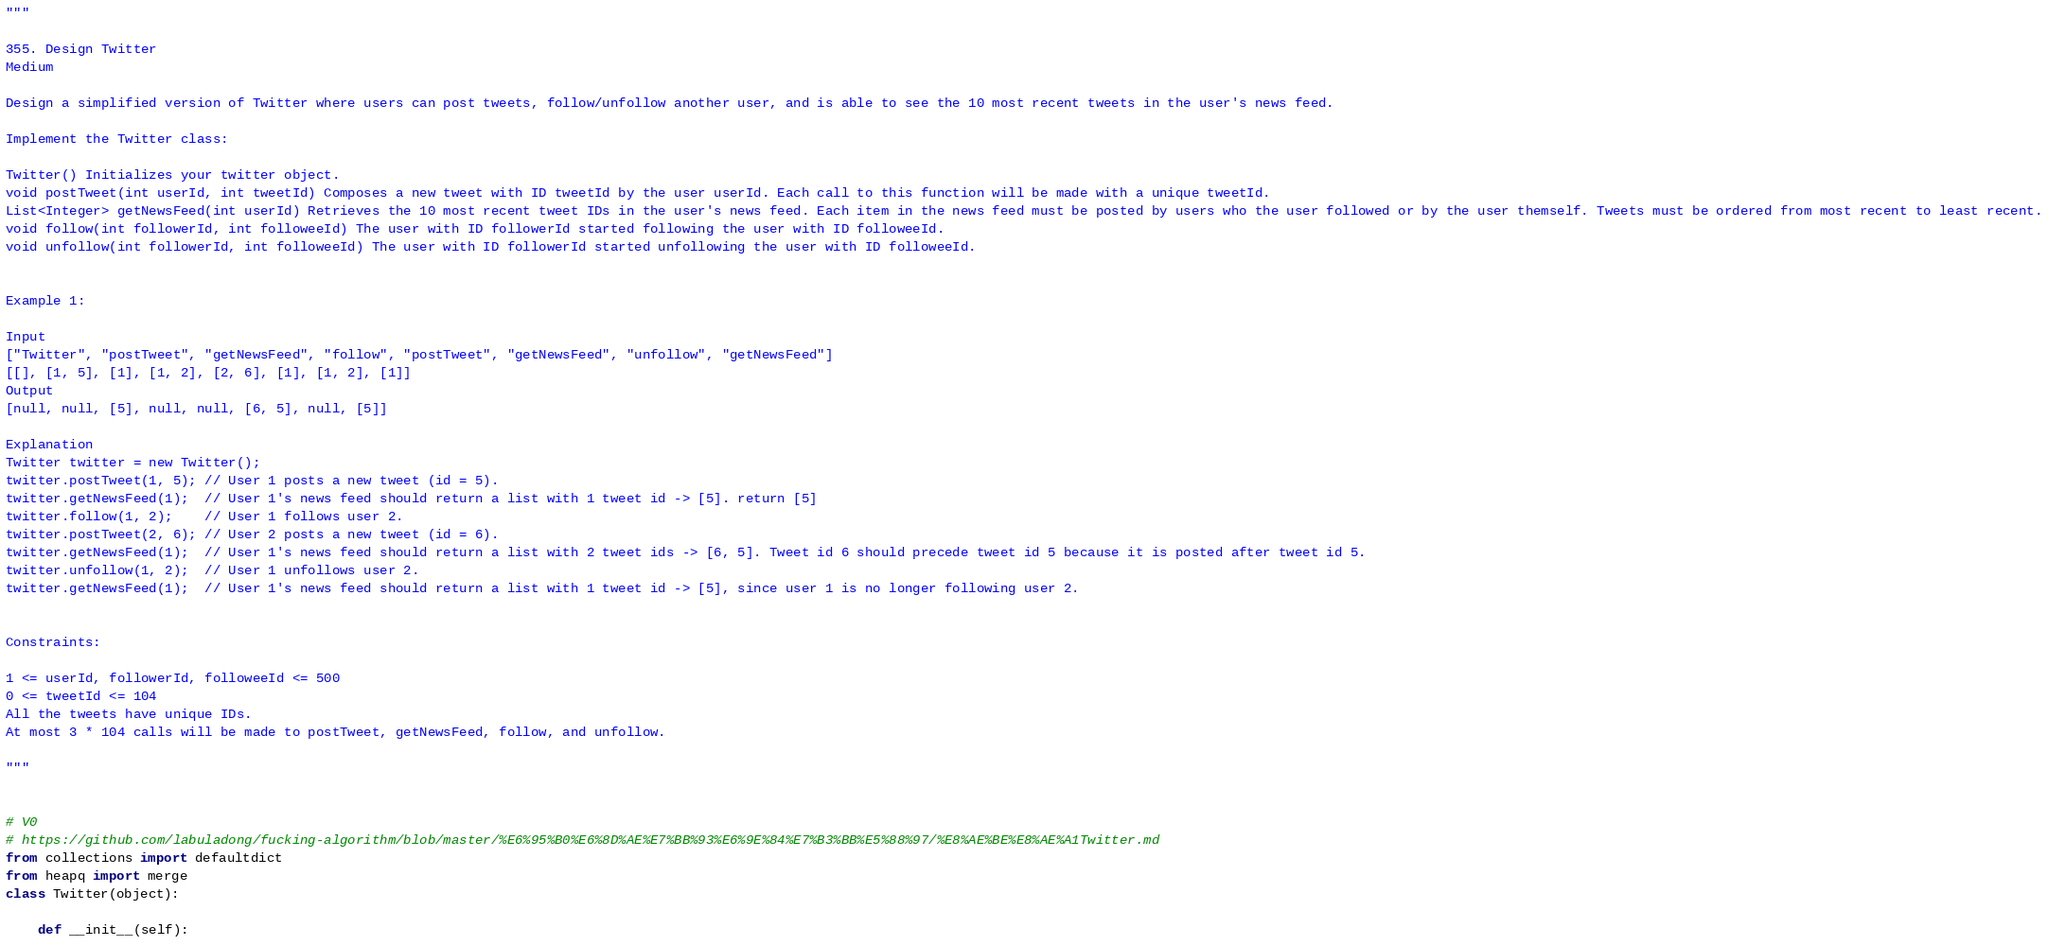Convert code to text. <code><loc_0><loc_0><loc_500><loc_500><_Python_>"""

355. Design Twitter
Medium

Design a simplified version of Twitter where users can post tweets, follow/unfollow another user, and is able to see the 10 most recent tweets in the user's news feed.

Implement the Twitter class:

Twitter() Initializes your twitter object.
void postTweet(int userId, int tweetId) Composes a new tweet with ID tweetId by the user userId. Each call to this function will be made with a unique tweetId.
List<Integer> getNewsFeed(int userId) Retrieves the 10 most recent tweet IDs in the user's news feed. Each item in the news feed must be posted by users who the user followed or by the user themself. Tweets must be ordered from most recent to least recent.
void follow(int followerId, int followeeId) The user with ID followerId started following the user with ID followeeId.
void unfollow(int followerId, int followeeId) The user with ID followerId started unfollowing the user with ID followeeId.
 

Example 1:

Input
["Twitter", "postTweet", "getNewsFeed", "follow", "postTweet", "getNewsFeed", "unfollow", "getNewsFeed"]
[[], [1, 5], [1], [1, 2], [2, 6], [1], [1, 2], [1]]
Output
[null, null, [5], null, null, [6, 5], null, [5]]

Explanation
Twitter twitter = new Twitter();
twitter.postTweet(1, 5); // User 1 posts a new tweet (id = 5).
twitter.getNewsFeed(1);  // User 1's news feed should return a list with 1 tweet id -> [5]. return [5]
twitter.follow(1, 2);    // User 1 follows user 2.
twitter.postTweet(2, 6); // User 2 posts a new tweet (id = 6).
twitter.getNewsFeed(1);  // User 1's news feed should return a list with 2 tweet ids -> [6, 5]. Tweet id 6 should precede tweet id 5 because it is posted after tweet id 5.
twitter.unfollow(1, 2);  // User 1 unfollows user 2.
twitter.getNewsFeed(1);  // User 1's news feed should return a list with 1 tweet id -> [5], since user 1 is no longer following user 2.
 

Constraints:

1 <= userId, followerId, followeeId <= 500
0 <= tweetId <= 104
All the tweets have unique IDs.
At most 3 * 104 calls will be made to postTweet, getNewsFeed, follow, and unfollow.

"""


# V0
# https://github.com/labuladong/fucking-algorithm/blob/master/%E6%95%B0%E6%8D%AE%E7%BB%93%E6%9E%84%E7%B3%BB%E5%88%97/%E8%AE%BE%E8%AE%A1Twitter.md
from collections import defaultdict
from heapq import merge
class Twitter(object):
    
    def __init__(self):</code> 